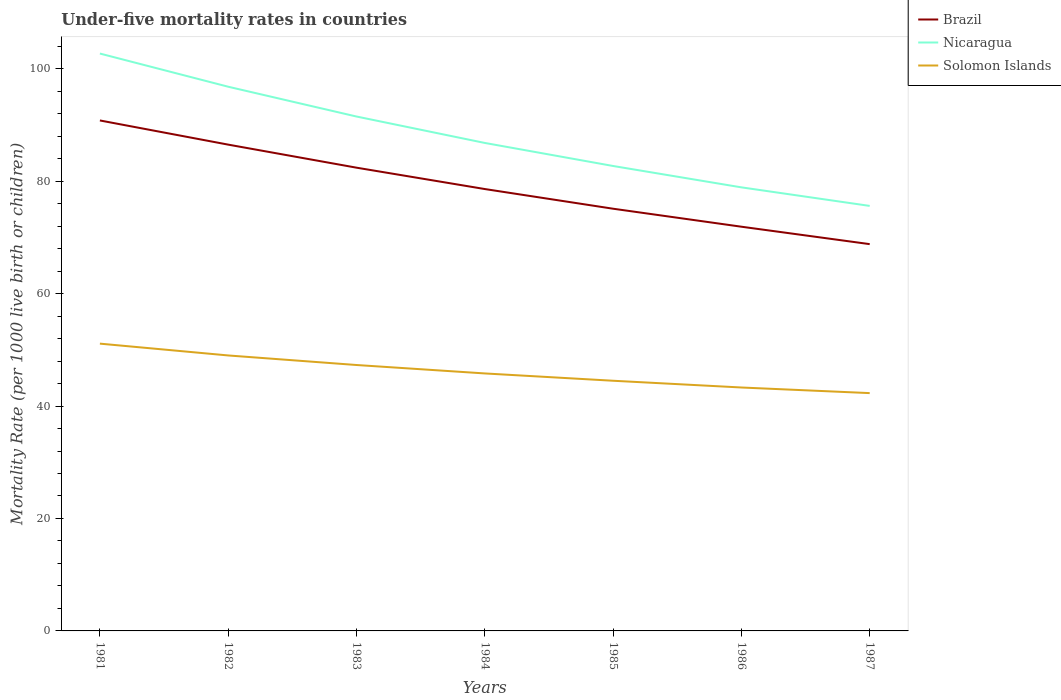How many different coloured lines are there?
Provide a succinct answer. 3. Across all years, what is the maximum under-five mortality rate in Solomon Islands?
Keep it short and to the point. 42.3. What is the total under-five mortality rate in Nicaragua in the graph?
Offer a very short reply. 27.1. What is the difference between the highest and the lowest under-five mortality rate in Brazil?
Offer a very short reply. 3. Is the under-five mortality rate in Solomon Islands strictly greater than the under-five mortality rate in Brazil over the years?
Offer a very short reply. Yes. How many years are there in the graph?
Provide a short and direct response. 7. Does the graph contain any zero values?
Ensure brevity in your answer.  No. Does the graph contain grids?
Offer a terse response. No. Where does the legend appear in the graph?
Offer a terse response. Top right. How many legend labels are there?
Give a very brief answer. 3. How are the legend labels stacked?
Give a very brief answer. Vertical. What is the title of the graph?
Ensure brevity in your answer.  Under-five mortality rates in countries. Does "Niger" appear as one of the legend labels in the graph?
Provide a succinct answer. No. What is the label or title of the X-axis?
Your response must be concise. Years. What is the label or title of the Y-axis?
Make the answer very short. Mortality Rate (per 1000 live birth or children). What is the Mortality Rate (per 1000 live birth or children) in Brazil in 1981?
Give a very brief answer. 90.8. What is the Mortality Rate (per 1000 live birth or children) in Nicaragua in 1981?
Provide a short and direct response. 102.7. What is the Mortality Rate (per 1000 live birth or children) in Solomon Islands in 1981?
Make the answer very short. 51.1. What is the Mortality Rate (per 1000 live birth or children) of Brazil in 1982?
Your answer should be compact. 86.5. What is the Mortality Rate (per 1000 live birth or children) in Nicaragua in 1982?
Offer a very short reply. 96.8. What is the Mortality Rate (per 1000 live birth or children) of Brazil in 1983?
Ensure brevity in your answer.  82.4. What is the Mortality Rate (per 1000 live birth or children) of Nicaragua in 1983?
Keep it short and to the point. 91.5. What is the Mortality Rate (per 1000 live birth or children) of Solomon Islands in 1983?
Give a very brief answer. 47.3. What is the Mortality Rate (per 1000 live birth or children) in Brazil in 1984?
Your answer should be very brief. 78.6. What is the Mortality Rate (per 1000 live birth or children) in Nicaragua in 1984?
Provide a short and direct response. 86.8. What is the Mortality Rate (per 1000 live birth or children) of Solomon Islands in 1984?
Your response must be concise. 45.8. What is the Mortality Rate (per 1000 live birth or children) of Brazil in 1985?
Offer a terse response. 75.1. What is the Mortality Rate (per 1000 live birth or children) of Nicaragua in 1985?
Keep it short and to the point. 82.7. What is the Mortality Rate (per 1000 live birth or children) in Solomon Islands in 1985?
Provide a succinct answer. 44.5. What is the Mortality Rate (per 1000 live birth or children) in Brazil in 1986?
Your answer should be compact. 71.9. What is the Mortality Rate (per 1000 live birth or children) of Nicaragua in 1986?
Your response must be concise. 78.9. What is the Mortality Rate (per 1000 live birth or children) of Solomon Islands in 1986?
Your response must be concise. 43.3. What is the Mortality Rate (per 1000 live birth or children) of Brazil in 1987?
Offer a very short reply. 68.8. What is the Mortality Rate (per 1000 live birth or children) of Nicaragua in 1987?
Make the answer very short. 75.6. What is the Mortality Rate (per 1000 live birth or children) in Solomon Islands in 1987?
Make the answer very short. 42.3. Across all years, what is the maximum Mortality Rate (per 1000 live birth or children) in Brazil?
Your answer should be compact. 90.8. Across all years, what is the maximum Mortality Rate (per 1000 live birth or children) of Nicaragua?
Your response must be concise. 102.7. Across all years, what is the maximum Mortality Rate (per 1000 live birth or children) of Solomon Islands?
Keep it short and to the point. 51.1. Across all years, what is the minimum Mortality Rate (per 1000 live birth or children) in Brazil?
Give a very brief answer. 68.8. Across all years, what is the minimum Mortality Rate (per 1000 live birth or children) of Nicaragua?
Your answer should be compact. 75.6. Across all years, what is the minimum Mortality Rate (per 1000 live birth or children) of Solomon Islands?
Keep it short and to the point. 42.3. What is the total Mortality Rate (per 1000 live birth or children) in Brazil in the graph?
Your response must be concise. 554.1. What is the total Mortality Rate (per 1000 live birth or children) in Nicaragua in the graph?
Provide a short and direct response. 615. What is the total Mortality Rate (per 1000 live birth or children) of Solomon Islands in the graph?
Ensure brevity in your answer.  323.3. What is the difference between the Mortality Rate (per 1000 live birth or children) in Solomon Islands in 1981 and that in 1983?
Keep it short and to the point. 3.8. What is the difference between the Mortality Rate (per 1000 live birth or children) of Brazil in 1981 and that in 1984?
Ensure brevity in your answer.  12.2. What is the difference between the Mortality Rate (per 1000 live birth or children) in Brazil in 1981 and that in 1985?
Make the answer very short. 15.7. What is the difference between the Mortality Rate (per 1000 live birth or children) in Nicaragua in 1981 and that in 1985?
Make the answer very short. 20. What is the difference between the Mortality Rate (per 1000 live birth or children) in Brazil in 1981 and that in 1986?
Your answer should be very brief. 18.9. What is the difference between the Mortality Rate (per 1000 live birth or children) of Nicaragua in 1981 and that in 1986?
Your response must be concise. 23.8. What is the difference between the Mortality Rate (per 1000 live birth or children) of Solomon Islands in 1981 and that in 1986?
Provide a succinct answer. 7.8. What is the difference between the Mortality Rate (per 1000 live birth or children) of Brazil in 1981 and that in 1987?
Provide a short and direct response. 22. What is the difference between the Mortality Rate (per 1000 live birth or children) of Nicaragua in 1981 and that in 1987?
Provide a succinct answer. 27.1. What is the difference between the Mortality Rate (per 1000 live birth or children) of Brazil in 1982 and that in 1983?
Your answer should be very brief. 4.1. What is the difference between the Mortality Rate (per 1000 live birth or children) of Solomon Islands in 1982 and that in 1984?
Give a very brief answer. 3.2. What is the difference between the Mortality Rate (per 1000 live birth or children) in Nicaragua in 1982 and that in 1985?
Give a very brief answer. 14.1. What is the difference between the Mortality Rate (per 1000 live birth or children) of Solomon Islands in 1982 and that in 1985?
Offer a very short reply. 4.5. What is the difference between the Mortality Rate (per 1000 live birth or children) in Brazil in 1982 and that in 1986?
Make the answer very short. 14.6. What is the difference between the Mortality Rate (per 1000 live birth or children) in Brazil in 1982 and that in 1987?
Offer a terse response. 17.7. What is the difference between the Mortality Rate (per 1000 live birth or children) in Nicaragua in 1982 and that in 1987?
Keep it short and to the point. 21.2. What is the difference between the Mortality Rate (per 1000 live birth or children) in Solomon Islands in 1982 and that in 1987?
Your answer should be very brief. 6.7. What is the difference between the Mortality Rate (per 1000 live birth or children) of Nicaragua in 1983 and that in 1984?
Offer a very short reply. 4.7. What is the difference between the Mortality Rate (per 1000 live birth or children) in Nicaragua in 1983 and that in 1986?
Provide a short and direct response. 12.6. What is the difference between the Mortality Rate (per 1000 live birth or children) in Solomon Islands in 1983 and that in 1986?
Keep it short and to the point. 4. What is the difference between the Mortality Rate (per 1000 live birth or children) of Nicaragua in 1983 and that in 1987?
Provide a short and direct response. 15.9. What is the difference between the Mortality Rate (per 1000 live birth or children) of Brazil in 1984 and that in 1985?
Keep it short and to the point. 3.5. What is the difference between the Mortality Rate (per 1000 live birth or children) of Solomon Islands in 1984 and that in 1985?
Offer a terse response. 1.3. What is the difference between the Mortality Rate (per 1000 live birth or children) in Nicaragua in 1984 and that in 1986?
Your answer should be compact. 7.9. What is the difference between the Mortality Rate (per 1000 live birth or children) of Solomon Islands in 1984 and that in 1986?
Your answer should be very brief. 2.5. What is the difference between the Mortality Rate (per 1000 live birth or children) of Brazil in 1984 and that in 1987?
Offer a very short reply. 9.8. What is the difference between the Mortality Rate (per 1000 live birth or children) of Solomon Islands in 1984 and that in 1987?
Ensure brevity in your answer.  3.5. What is the difference between the Mortality Rate (per 1000 live birth or children) of Brazil in 1985 and that in 1986?
Keep it short and to the point. 3.2. What is the difference between the Mortality Rate (per 1000 live birth or children) in Solomon Islands in 1985 and that in 1986?
Ensure brevity in your answer.  1.2. What is the difference between the Mortality Rate (per 1000 live birth or children) in Brazil in 1986 and that in 1987?
Your answer should be compact. 3.1. What is the difference between the Mortality Rate (per 1000 live birth or children) of Nicaragua in 1986 and that in 1987?
Offer a very short reply. 3.3. What is the difference between the Mortality Rate (per 1000 live birth or children) of Solomon Islands in 1986 and that in 1987?
Keep it short and to the point. 1. What is the difference between the Mortality Rate (per 1000 live birth or children) of Brazil in 1981 and the Mortality Rate (per 1000 live birth or children) of Solomon Islands in 1982?
Make the answer very short. 41.8. What is the difference between the Mortality Rate (per 1000 live birth or children) in Nicaragua in 1981 and the Mortality Rate (per 1000 live birth or children) in Solomon Islands in 1982?
Offer a very short reply. 53.7. What is the difference between the Mortality Rate (per 1000 live birth or children) in Brazil in 1981 and the Mortality Rate (per 1000 live birth or children) in Nicaragua in 1983?
Offer a very short reply. -0.7. What is the difference between the Mortality Rate (per 1000 live birth or children) of Brazil in 1981 and the Mortality Rate (per 1000 live birth or children) of Solomon Islands in 1983?
Make the answer very short. 43.5. What is the difference between the Mortality Rate (per 1000 live birth or children) of Nicaragua in 1981 and the Mortality Rate (per 1000 live birth or children) of Solomon Islands in 1983?
Your answer should be compact. 55.4. What is the difference between the Mortality Rate (per 1000 live birth or children) in Brazil in 1981 and the Mortality Rate (per 1000 live birth or children) in Nicaragua in 1984?
Offer a terse response. 4. What is the difference between the Mortality Rate (per 1000 live birth or children) in Nicaragua in 1981 and the Mortality Rate (per 1000 live birth or children) in Solomon Islands in 1984?
Your answer should be compact. 56.9. What is the difference between the Mortality Rate (per 1000 live birth or children) of Brazil in 1981 and the Mortality Rate (per 1000 live birth or children) of Solomon Islands in 1985?
Give a very brief answer. 46.3. What is the difference between the Mortality Rate (per 1000 live birth or children) of Nicaragua in 1981 and the Mortality Rate (per 1000 live birth or children) of Solomon Islands in 1985?
Provide a short and direct response. 58.2. What is the difference between the Mortality Rate (per 1000 live birth or children) of Brazil in 1981 and the Mortality Rate (per 1000 live birth or children) of Solomon Islands in 1986?
Provide a succinct answer. 47.5. What is the difference between the Mortality Rate (per 1000 live birth or children) of Nicaragua in 1981 and the Mortality Rate (per 1000 live birth or children) of Solomon Islands in 1986?
Your answer should be compact. 59.4. What is the difference between the Mortality Rate (per 1000 live birth or children) of Brazil in 1981 and the Mortality Rate (per 1000 live birth or children) of Nicaragua in 1987?
Your answer should be very brief. 15.2. What is the difference between the Mortality Rate (per 1000 live birth or children) in Brazil in 1981 and the Mortality Rate (per 1000 live birth or children) in Solomon Islands in 1987?
Ensure brevity in your answer.  48.5. What is the difference between the Mortality Rate (per 1000 live birth or children) in Nicaragua in 1981 and the Mortality Rate (per 1000 live birth or children) in Solomon Islands in 1987?
Give a very brief answer. 60.4. What is the difference between the Mortality Rate (per 1000 live birth or children) of Brazil in 1982 and the Mortality Rate (per 1000 live birth or children) of Solomon Islands in 1983?
Keep it short and to the point. 39.2. What is the difference between the Mortality Rate (per 1000 live birth or children) of Nicaragua in 1982 and the Mortality Rate (per 1000 live birth or children) of Solomon Islands in 1983?
Keep it short and to the point. 49.5. What is the difference between the Mortality Rate (per 1000 live birth or children) in Brazil in 1982 and the Mortality Rate (per 1000 live birth or children) in Solomon Islands in 1984?
Keep it short and to the point. 40.7. What is the difference between the Mortality Rate (per 1000 live birth or children) of Brazil in 1982 and the Mortality Rate (per 1000 live birth or children) of Nicaragua in 1985?
Make the answer very short. 3.8. What is the difference between the Mortality Rate (per 1000 live birth or children) in Nicaragua in 1982 and the Mortality Rate (per 1000 live birth or children) in Solomon Islands in 1985?
Provide a succinct answer. 52.3. What is the difference between the Mortality Rate (per 1000 live birth or children) in Brazil in 1982 and the Mortality Rate (per 1000 live birth or children) in Nicaragua in 1986?
Keep it short and to the point. 7.6. What is the difference between the Mortality Rate (per 1000 live birth or children) of Brazil in 1982 and the Mortality Rate (per 1000 live birth or children) of Solomon Islands in 1986?
Your answer should be compact. 43.2. What is the difference between the Mortality Rate (per 1000 live birth or children) of Nicaragua in 1982 and the Mortality Rate (per 1000 live birth or children) of Solomon Islands in 1986?
Offer a very short reply. 53.5. What is the difference between the Mortality Rate (per 1000 live birth or children) in Brazil in 1982 and the Mortality Rate (per 1000 live birth or children) in Nicaragua in 1987?
Ensure brevity in your answer.  10.9. What is the difference between the Mortality Rate (per 1000 live birth or children) in Brazil in 1982 and the Mortality Rate (per 1000 live birth or children) in Solomon Islands in 1987?
Keep it short and to the point. 44.2. What is the difference between the Mortality Rate (per 1000 live birth or children) in Nicaragua in 1982 and the Mortality Rate (per 1000 live birth or children) in Solomon Islands in 1987?
Give a very brief answer. 54.5. What is the difference between the Mortality Rate (per 1000 live birth or children) of Brazil in 1983 and the Mortality Rate (per 1000 live birth or children) of Solomon Islands in 1984?
Give a very brief answer. 36.6. What is the difference between the Mortality Rate (per 1000 live birth or children) of Nicaragua in 1983 and the Mortality Rate (per 1000 live birth or children) of Solomon Islands in 1984?
Offer a very short reply. 45.7. What is the difference between the Mortality Rate (per 1000 live birth or children) in Brazil in 1983 and the Mortality Rate (per 1000 live birth or children) in Solomon Islands in 1985?
Your answer should be very brief. 37.9. What is the difference between the Mortality Rate (per 1000 live birth or children) of Brazil in 1983 and the Mortality Rate (per 1000 live birth or children) of Nicaragua in 1986?
Offer a terse response. 3.5. What is the difference between the Mortality Rate (per 1000 live birth or children) in Brazil in 1983 and the Mortality Rate (per 1000 live birth or children) in Solomon Islands in 1986?
Make the answer very short. 39.1. What is the difference between the Mortality Rate (per 1000 live birth or children) of Nicaragua in 1983 and the Mortality Rate (per 1000 live birth or children) of Solomon Islands in 1986?
Offer a very short reply. 48.2. What is the difference between the Mortality Rate (per 1000 live birth or children) in Brazil in 1983 and the Mortality Rate (per 1000 live birth or children) in Solomon Islands in 1987?
Make the answer very short. 40.1. What is the difference between the Mortality Rate (per 1000 live birth or children) of Nicaragua in 1983 and the Mortality Rate (per 1000 live birth or children) of Solomon Islands in 1987?
Keep it short and to the point. 49.2. What is the difference between the Mortality Rate (per 1000 live birth or children) in Brazil in 1984 and the Mortality Rate (per 1000 live birth or children) in Nicaragua in 1985?
Offer a terse response. -4.1. What is the difference between the Mortality Rate (per 1000 live birth or children) in Brazil in 1984 and the Mortality Rate (per 1000 live birth or children) in Solomon Islands in 1985?
Your answer should be very brief. 34.1. What is the difference between the Mortality Rate (per 1000 live birth or children) of Nicaragua in 1984 and the Mortality Rate (per 1000 live birth or children) of Solomon Islands in 1985?
Your answer should be very brief. 42.3. What is the difference between the Mortality Rate (per 1000 live birth or children) in Brazil in 1984 and the Mortality Rate (per 1000 live birth or children) in Solomon Islands in 1986?
Offer a very short reply. 35.3. What is the difference between the Mortality Rate (per 1000 live birth or children) in Nicaragua in 1984 and the Mortality Rate (per 1000 live birth or children) in Solomon Islands in 1986?
Your response must be concise. 43.5. What is the difference between the Mortality Rate (per 1000 live birth or children) of Brazil in 1984 and the Mortality Rate (per 1000 live birth or children) of Nicaragua in 1987?
Keep it short and to the point. 3. What is the difference between the Mortality Rate (per 1000 live birth or children) of Brazil in 1984 and the Mortality Rate (per 1000 live birth or children) of Solomon Islands in 1987?
Offer a terse response. 36.3. What is the difference between the Mortality Rate (per 1000 live birth or children) of Nicaragua in 1984 and the Mortality Rate (per 1000 live birth or children) of Solomon Islands in 1987?
Provide a succinct answer. 44.5. What is the difference between the Mortality Rate (per 1000 live birth or children) of Brazil in 1985 and the Mortality Rate (per 1000 live birth or children) of Nicaragua in 1986?
Give a very brief answer. -3.8. What is the difference between the Mortality Rate (per 1000 live birth or children) of Brazil in 1985 and the Mortality Rate (per 1000 live birth or children) of Solomon Islands in 1986?
Give a very brief answer. 31.8. What is the difference between the Mortality Rate (per 1000 live birth or children) in Nicaragua in 1985 and the Mortality Rate (per 1000 live birth or children) in Solomon Islands in 1986?
Your answer should be very brief. 39.4. What is the difference between the Mortality Rate (per 1000 live birth or children) of Brazil in 1985 and the Mortality Rate (per 1000 live birth or children) of Nicaragua in 1987?
Make the answer very short. -0.5. What is the difference between the Mortality Rate (per 1000 live birth or children) in Brazil in 1985 and the Mortality Rate (per 1000 live birth or children) in Solomon Islands in 1987?
Ensure brevity in your answer.  32.8. What is the difference between the Mortality Rate (per 1000 live birth or children) in Nicaragua in 1985 and the Mortality Rate (per 1000 live birth or children) in Solomon Islands in 1987?
Offer a terse response. 40.4. What is the difference between the Mortality Rate (per 1000 live birth or children) of Brazil in 1986 and the Mortality Rate (per 1000 live birth or children) of Nicaragua in 1987?
Give a very brief answer. -3.7. What is the difference between the Mortality Rate (per 1000 live birth or children) in Brazil in 1986 and the Mortality Rate (per 1000 live birth or children) in Solomon Islands in 1987?
Your answer should be very brief. 29.6. What is the difference between the Mortality Rate (per 1000 live birth or children) of Nicaragua in 1986 and the Mortality Rate (per 1000 live birth or children) of Solomon Islands in 1987?
Provide a short and direct response. 36.6. What is the average Mortality Rate (per 1000 live birth or children) in Brazil per year?
Your response must be concise. 79.16. What is the average Mortality Rate (per 1000 live birth or children) in Nicaragua per year?
Provide a succinct answer. 87.86. What is the average Mortality Rate (per 1000 live birth or children) in Solomon Islands per year?
Provide a succinct answer. 46.19. In the year 1981, what is the difference between the Mortality Rate (per 1000 live birth or children) in Brazil and Mortality Rate (per 1000 live birth or children) in Nicaragua?
Your answer should be compact. -11.9. In the year 1981, what is the difference between the Mortality Rate (per 1000 live birth or children) of Brazil and Mortality Rate (per 1000 live birth or children) of Solomon Islands?
Offer a terse response. 39.7. In the year 1981, what is the difference between the Mortality Rate (per 1000 live birth or children) in Nicaragua and Mortality Rate (per 1000 live birth or children) in Solomon Islands?
Your answer should be compact. 51.6. In the year 1982, what is the difference between the Mortality Rate (per 1000 live birth or children) in Brazil and Mortality Rate (per 1000 live birth or children) in Solomon Islands?
Make the answer very short. 37.5. In the year 1982, what is the difference between the Mortality Rate (per 1000 live birth or children) in Nicaragua and Mortality Rate (per 1000 live birth or children) in Solomon Islands?
Ensure brevity in your answer.  47.8. In the year 1983, what is the difference between the Mortality Rate (per 1000 live birth or children) in Brazil and Mortality Rate (per 1000 live birth or children) in Solomon Islands?
Offer a terse response. 35.1. In the year 1983, what is the difference between the Mortality Rate (per 1000 live birth or children) of Nicaragua and Mortality Rate (per 1000 live birth or children) of Solomon Islands?
Your answer should be compact. 44.2. In the year 1984, what is the difference between the Mortality Rate (per 1000 live birth or children) in Brazil and Mortality Rate (per 1000 live birth or children) in Solomon Islands?
Make the answer very short. 32.8. In the year 1984, what is the difference between the Mortality Rate (per 1000 live birth or children) in Nicaragua and Mortality Rate (per 1000 live birth or children) in Solomon Islands?
Provide a short and direct response. 41. In the year 1985, what is the difference between the Mortality Rate (per 1000 live birth or children) of Brazil and Mortality Rate (per 1000 live birth or children) of Solomon Islands?
Your answer should be compact. 30.6. In the year 1985, what is the difference between the Mortality Rate (per 1000 live birth or children) of Nicaragua and Mortality Rate (per 1000 live birth or children) of Solomon Islands?
Keep it short and to the point. 38.2. In the year 1986, what is the difference between the Mortality Rate (per 1000 live birth or children) in Brazil and Mortality Rate (per 1000 live birth or children) in Nicaragua?
Provide a short and direct response. -7. In the year 1986, what is the difference between the Mortality Rate (per 1000 live birth or children) of Brazil and Mortality Rate (per 1000 live birth or children) of Solomon Islands?
Provide a succinct answer. 28.6. In the year 1986, what is the difference between the Mortality Rate (per 1000 live birth or children) in Nicaragua and Mortality Rate (per 1000 live birth or children) in Solomon Islands?
Keep it short and to the point. 35.6. In the year 1987, what is the difference between the Mortality Rate (per 1000 live birth or children) of Brazil and Mortality Rate (per 1000 live birth or children) of Nicaragua?
Your answer should be very brief. -6.8. In the year 1987, what is the difference between the Mortality Rate (per 1000 live birth or children) in Nicaragua and Mortality Rate (per 1000 live birth or children) in Solomon Islands?
Your answer should be compact. 33.3. What is the ratio of the Mortality Rate (per 1000 live birth or children) of Brazil in 1981 to that in 1982?
Your response must be concise. 1.05. What is the ratio of the Mortality Rate (per 1000 live birth or children) of Nicaragua in 1981 to that in 1982?
Your answer should be very brief. 1.06. What is the ratio of the Mortality Rate (per 1000 live birth or children) in Solomon Islands in 1981 to that in 1982?
Offer a terse response. 1.04. What is the ratio of the Mortality Rate (per 1000 live birth or children) in Brazil in 1981 to that in 1983?
Offer a very short reply. 1.1. What is the ratio of the Mortality Rate (per 1000 live birth or children) in Nicaragua in 1981 to that in 1983?
Offer a very short reply. 1.12. What is the ratio of the Mortality Rate (per 1000 live birth or children) in Solomon Islands in 1981 to that in 1983?
Your response must be concise. 1.08. What is the ratio of the Mortality Rate (per 1000 live birth or children) of Brazil in 1981 to that in 1984?
Offer a very short reply. 1.16. What is the ratio of the Mortality Rate (per 1000 live birth or children) in Nicaragua in 1981 to that in 1984?
Keep it short and to the point. 1.18. What is the ratio of the Mortality Rate (per 1000 live birth or children) of Solomon Islands in 1981 to that in 1984?
Provide a short and direct response. 1.12. What is the ratio of the Mortality Rate (per 1000 live birth or children) of Brazil in 1981 to that in 1985?
Provide a succinct answer. 1.21. What is the ratio of the Mortality Rate (per 1000 live birth or children) in Nicaragua in 1981 to that in 1985?
Your answer should be very brief. 1.24. What is the ratio of the Mortality Rate (per 1000 live birth or children) of Solomon Islands in 1981 to that in 1985?
Offer a terse response. 1.15. What is the ratio of the Mortality Rate (per 1000 live birth or children) in Brazil in 1981 to that in 1986?
Your response must be concise. 1.26. What is the ratio of the Mortality Rate (per 1000 live birth or children) in Nicaragua in 1981 to that in 1986?
Provide a short and direct response. 1.3. What is the ratio of the Mortality Rate (per 1000 live birth or children) in Solomon Islands in 1981 to that in 1986?
Provide a short and direct response. 1.18. What is the ratio of the Mortality Rate (per 1000 live birth or children) of Brazil in 1981 to that in 1987?
Ensure brevity in your answer.  1.32. What is the ratio of the Mortality Rate (per 1000 live birth or children) of Nicaragua in 1981 to that in 1987?
Keep it short and to the point. 1.36. What is the ratio of the Mortality Rate (per 1000 live birth or children) in Solomon Islands in 1981 to that in 1987?
Make the answer very short. 1.21. What is the ratio of the Mortality Rate (per 1000 live birth or children) of Brazil in 1982 to that in 1983?
Your response must be concise. 1.05. What is the ratio of the Mortality Rate (per 1000 live birth or children) of Nicaragua in 1982 to that in 1983?
Offer a terse response. 1.06. What is the ratio of the Mortality Rate (per 1000 live birth or children) of Solomon Islands in 1982 to that in 1983?
Keep it short and to the point. 1.04. What is the ratio of the Mortality Rate (per 1000 live birth or children) in Brazil in 1982 to that in 1984?
Give a very brief answer. 1.1. What is the ratio of the Mortality Rate (per 1000 live birth or children) of Nicaragua in 1982 to that in 1984?
Offer a terse response. 1.12. What is the ratio of the Mortality Rate (per 1000 live birth or children) in Solomon Islands in 1982 to that in 1984?
Offer a terse response. 1.07. What is the ratio of the Mortality Rate (per 1000 live birth or children) in Brazil in 1982 to that in 1985?
Your response must be concise. 1.15. What is the ratio of the Mortality Rate (per 1000 live birth or children) in Nicaragua in 1982 to that in 1985?
Offer a very short reply. 1.17. What is the ratio of the Mortality Rate (per 1000 live birth or children) of Solomon Islands in 1982 to that in 1985?
Ensure brevity in your answer.  1.1. What is the ratio of the Mortality Rate (per 1000 live birth or children) of Brazil in 1982 to that in 1986?
Ensure brevity in your answer.  1.2. What is the ratio of the Mortality Rate (per 1000 live birth or children) of Nicaragua in 1982 to that in 1986?
Make the answer very short. 1.23. What is the ratio of the Mortality Rate (per 1000 live birth or children) in Solomon Islands in 1982 to that in 1986?
Keep it short and to the point. 1.13. What is the ratio of the Mortality Rate (per 1000 live birth or children) of Brazil in 1982 to that in 1987?
Ensure brevity in your answer.  1.26. What is the ratio of the Mortality Rate (per 1000 live birth or children) of Nicaragua in 1982 to that in 1987?
Make the answer very short. 1.28. What is the ratio of the Mortality Rate (per 1000 live birth or children) of Solomon Islands in 1982 to that in 1987?
Make the answer very short. 1.16. What is the ratio of the Mortality Rate (per 1000 live birth or children) of Brazil in 1983 to that in 1984?
Provide a short and direct response. 1.05. What is the ratio of the Mortality Rate (per 1000 live birth or children) in Nicaragua in 1983 to that in 1984?
Offer a very short reply. 1.05. What is the ratio of the Mortality Rate (per 1000 live birth or children) of Solomon Islands in 1983 to that in 1984?
Make the answer very short. 1.03. What is the ratio of the Mortality Rate (per 1000 live birth or children) of Brazil in 1983 to that in 1985?
Provide a short and direct response. 1.1. What is the ratio of the Mortality Rate (per 1000 live birth or children) in Nicaragua in 1983 to that in 1985?
Give a very brief answer. 1.11. What is the ratio of the Mortality Rate (per 1000 live birth or children) in Solomon Islands in 1983 to that in 1985?
Your response must be concise. 1.06. What is the ratio of the Mortality Rate (per 1000 live birth or children) in Brazil in 1983 to that in 1986?
Provide a short and direct response. 1.15. What is the ratio of the Mortality Rate (per 1000 live birth or children) in Nicaragua in 1983 to that in 1986?
Offer a terse response. 1.16. What is the ratio of the Mortality Rate (per 1000 live birth or children) in Solomon Islands in 1983 to that in 1986?
Provide a succinct answer. 1.09. What is the ratio of the Mortality Rate (per 1000 live birth or children) in Brazil in 1983 to that in 1987?
Make the answer very short. 1.2. What is the ratio of the Mortality Rate (per 1000 live birth or children) in Nicaragua in 1983 to that in 1987?
Give a very brief answer. 1.21. What is the ratio of the Mortality Rate (per 1000 live birth or children) in Solomon Islands in 1983 to that in 1987?
Ensure brevity in your answer.  1.12. What is the ratio of the Mortality Rate (per 1000 live birth or children) in Brazil in 1984 to that in 1985?
Make the answer very short. 1.05. What is the ratio of the Mortality Rate (per 1000 live birth or children) in Nicaragua in 1984 to that in 1985?
Offer a very short reply. 1.05. What is the ratio of the Mortality Rate (per 1000 live birth or children) in Solomon Islands in 1984 to that in 1985?
Your response must be concise. 1.03. What is the ratio of the Mortality Rate (per 1000 live birth or children) in Brazil in 1984 to that in 1986?
Keep it short and to the point. 1.09. What is the ratio of the Mortality Rate (per 1000 live birth or children) in Nicaragua in 1984 to that in 1986?
Provide a short and direct response. 1.1. What is the ratio of the Mortality Rate (per 1000 live birth or children) of Solomon Islands in 1984 to that in 1986?
Provide a short and direct response. 1.06. What is the ratio of the Mortality Rate (per 1000 live birth or children) of Brazil in 1984 to that in 1987?
Your answer should be compact. 1.14. What is the ratio of the Mortality Rate (per 1000 live birth or children) in Nicaragua in 1984 to that in 1987?
Ensure brevity in your answer.  1.15. What is the ratio of the Mortality Rate (per 1000 live birth or children) of Solomon Islands in 1984 to that in 1987?
Keep it short and to the point. 1.08. What is the ratio of the Mortality Rate (per 1000 live birth or children) in Brazil in 1985 to that in 1986?
Offer a very short reply. 1.04. What is the ratio of the Mortality Rate (per 1000 live birth or children) of Nicaragua in 1985 to that in 1986?
Keep it short and to the point. 1.05. What is the ratio of the Mortality Rate (per 1000 live birth or children) of Solomon Islands in 1985 to that in 1986?
Provide a short and direct response. 1.03. What is the ratio of the Mortality Rate (per 1000 live birth or children) in Brazil in 1985 to that in 1987?
Your answer should be very brief. 1.09. What is the ratio of the Mortality Rate (per 1000 live birth or children) of Nicaragua in 1985 to that in 1987?
Provide a short and direct response. 1.09. What is the ratio of the Mortality Rate (per 1000 live birth or children) in Solomon Islands in 1985 to that in 1987?
Your answer should be very brief. 1.05. What is the ratio of the Mortality Rate (per 1000 live birth or children) of Brazil in 1986 to that in 1987?
Your response must be concise. 1.05. What is the ratio of the Mortality Rate (per 1000 live birth or children) of Nicaragua in 1986 to that in 1987?
Your answer should be very brief. 1.04. What is the ratio of the Mortality Rate (per 1000 live birth or children) of Solomon Islands in 1986 to that in 1987?
Ensure brevity in your answer.  1.02. What is the difference between the highest and the lowest Mortality Rate (per 1000 live birth or children) in Brazil?
Provide a succinct answer. 22. What is the difference between the highest and the lowest Mortality Rate (per 1000 live birth or children) of Nicaragua?
Give a very brief answer. 27.1. 